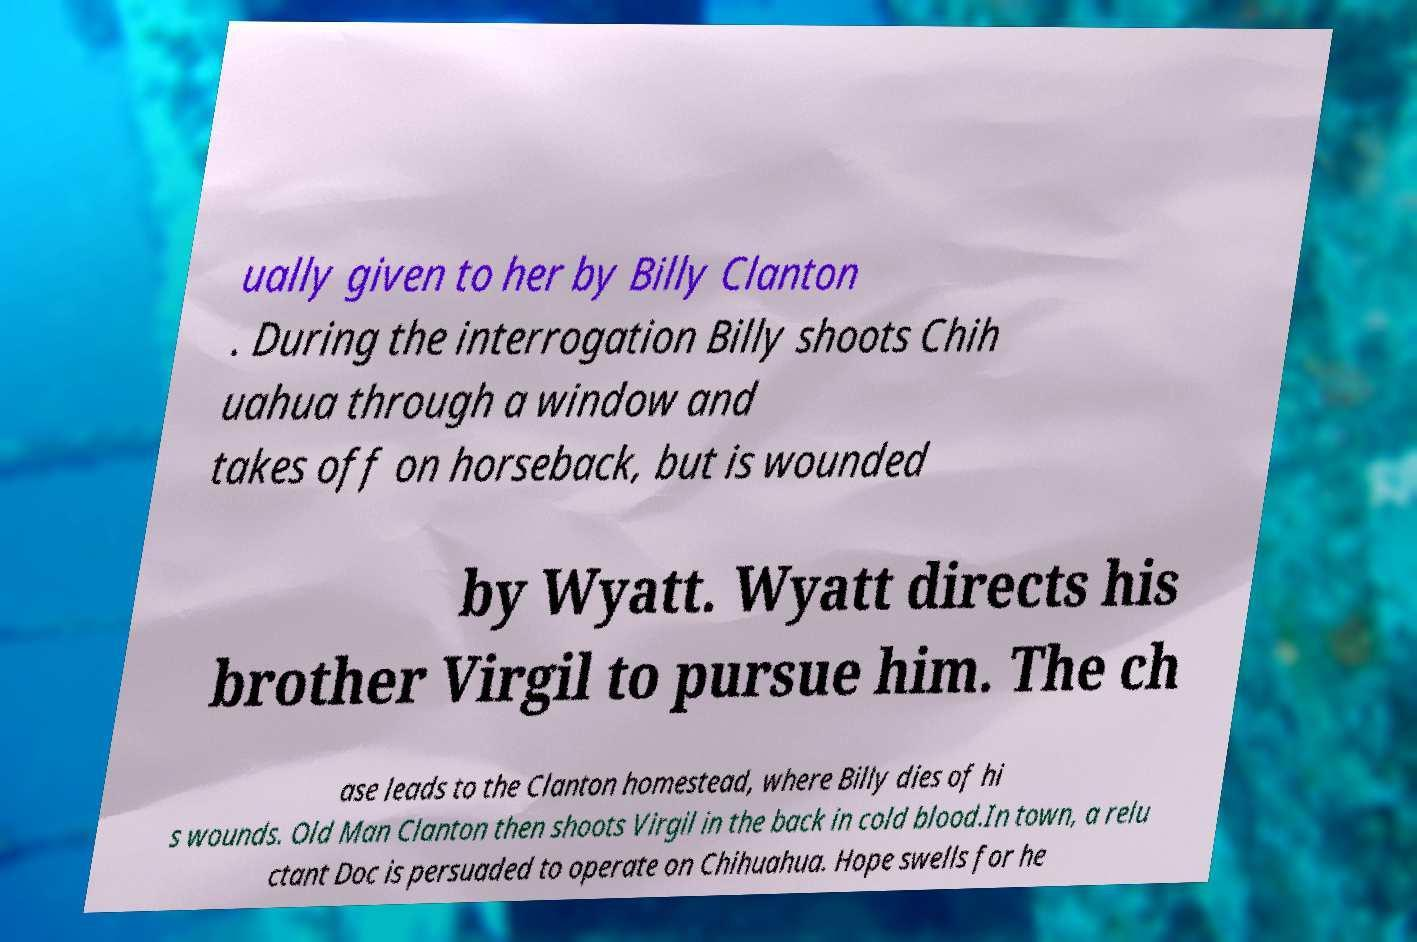Could you extract and type out the text from this image? ually given to her by Billy Clanton . During the interrogation Billy shoots Chih uahua through a window and takes off on horseback, but is wounded by Wyatt. Wyatt directs his brother Virgil to pursue him. The ch ase leads to the Clanton homestead, where Billy dies of hi s wounds. Old Man Clanton then shoots Virgil in the back in cold blood.In town, a relu ctant Doc is persuaded to operate on Chihuahua. Hope swells for he 